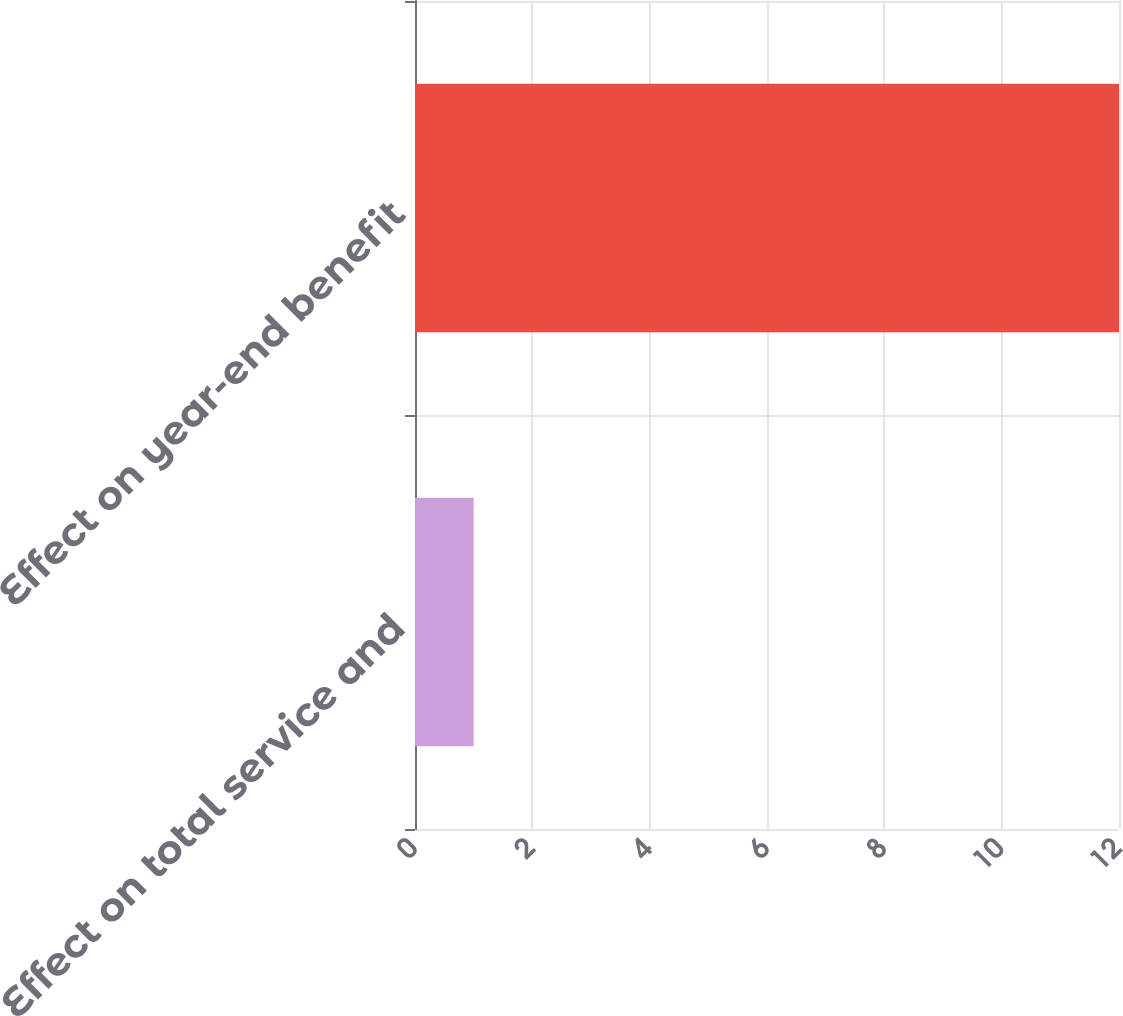Convert chart. <chart><loc_0><loc_0><loc_500><loc_500><bar_chart><fcel>Effect on total service and<fcel>Effect on year-end benefit<nl><fcel>1<fcel>12<nl></chart> 